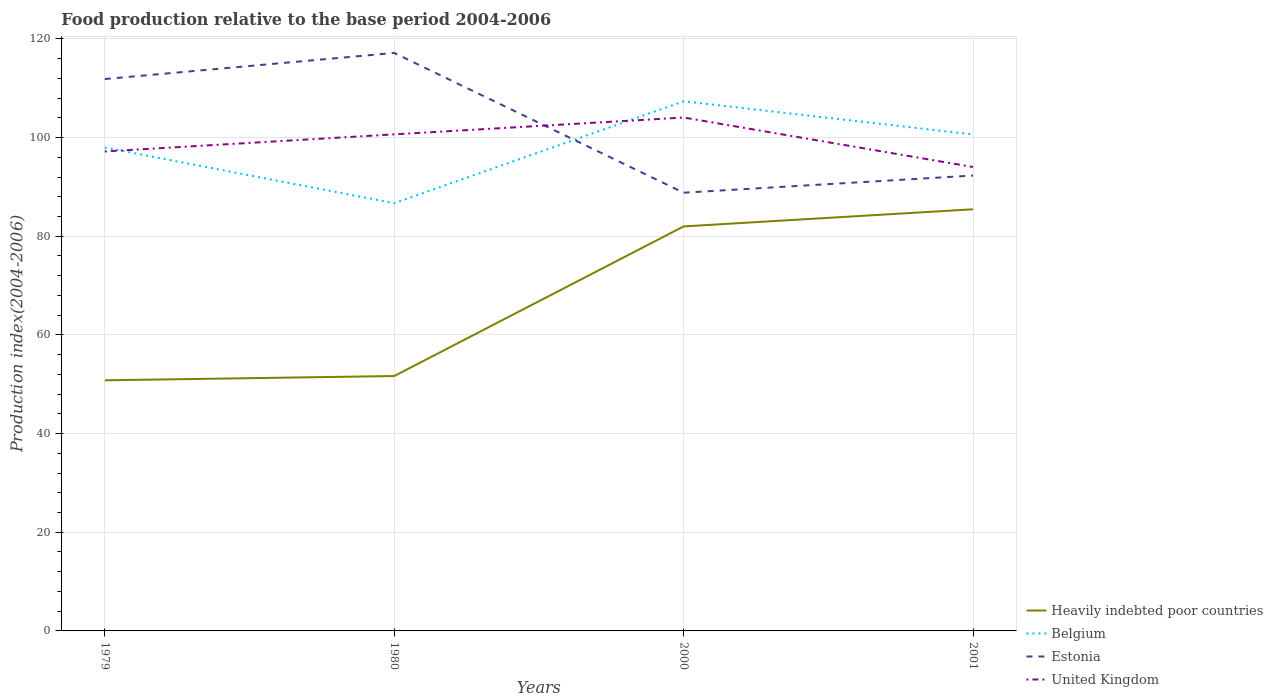How many different coloured lines are there?
Provide a succinct answer. 4. Does the line corresponding to Estonia intersect with the line corresponding to United Kingdom?
Your response must be concise. Yes. Across all years, what is the maximum food production index in Belgium?
Make the answer very short. 86.7. In which year was the food production index in Belgium maximum?
Offer a very short reply. 1980. What is the total food production index in Estonia in the graph?
Keep it short and to the point. 24.85. What is the difference between the highest and the second highest food production index in United Kingdom?
Give a very brief answer. 10.03. What is the difference between the highest and the lowest food production index in Estonia?
Provide a short and direct response. 2. How many years are there in the graph?
Your answer should be compact. 4. Does the graph contain any zero values?
Provide a succinct answer. No. How are the legend labels stacked?
Offer a very short reply. Vertical. What is the title of the graph?
Provide a short and direct response. Food production relative to the base period 2004-2006. Does "Trinidad and Tobago" appear as one of the legend labels in the graph?
Provide a short and direct response. No. What is the label or title of the X-axis?
Offer a terse response. Years. What is the label or title of the Y-axis?
Offer a terse response. Production index(2004-2006). What is the Production index(2004-2006) in Heavily indebted poor countries in 1979?
Provide a succinct answer. 50.8. What is the Production index(2004-2006) in Belgium in 1979?
Make the answer very short. 97.99. What is the Production index(2004-2006) of Estonia in 1979?
Your answer should be compact. 111.87. What is the Production index(2004-2006) of United Kingdom in 1979?
Offer a very short reply. 97.19. What is the Production index(2004-2006) of Heavily indebted poor countries in 1980?
Give a very brief answer. 51.67. What is the Production index(2004-2006) in Belgium in 1980?
Offer a terse response. 86.7. What is the Production index(2004-2006) of Estonia in 1980?
Provide a succinct answer. 117.16. What is the Production index(2004-2006) of United Kingdom in 1980?
Your response must be concise. 100.66. What is the Production index(2004-2006) in Heavily indebted poor countries in 2000?
Provide a succinct answer. 82. What is the Production index(2004-2006) in Belgium in 2000?
Offer a very short reply. 107.36. What is the Production index(2004-2006) of Estonia in 2000?
Keep it short and to the point. 88.83. What is the Production index(2004-2006) of United Kingdom in 2000?
Your answer should be compact. 104.07. What is the Production index(2004-2006) of Heavily indebted poor countries in 2001?
Offer a terse response. 85.47. What is the Production index(2004-2006) in Belgium in 2001?
Offer a very short reply. 100.64. What is the Production index(2004-2006) of Estonia in 2001?
Keep it short and to the point. 92.31. What is the Production index(2004-2006) in United Kingdom in 2001?
Your answer should be very brief. 94.04. Across all years, what is the maximum Production index(2004-2006) in Heavily indebted poor countries?
Your answer should be very brief. 85.47. Across all years, what is the maximum Production index(2004-2006) of Belgium?
Offer a terse response. 107.36. Across all years, what is the maximum Production index(2004-2006) in Estonia?
Provide a succinct answer. 117.16. Across all years, what is the maximum Production index(2004-2006) in United Kingdom?
Your answer should be compact. 104.07. Across all years, what is the minimum Production index(2004-2006) in Heavily indebted poor countries?
Make the answer very short. 50.8. Across all years, what is the minimum Production index(2004-2006) in Belgium?
Ensure brevity in your answer.  86.7. Across all years, what is the minimum Production index(2004-2006) in Estonia?
Give a very brief answer. 88.83. Across all years, what is the minimum Production index(2004-2006) in United Kingdom?
Your response must be concise. 94.04. What is the total Production index(2004-2006) of Heavily indebted poor countries in the graph?
Ensure brevity in your answer.  269.93. What is the total Production index(2004-2006) in Belgium in the graph?
Provide a succinct answer. 392.69. What is the total Production index(2004-2006) in Estonia in the graph?
Make the answer very short. 410.17. What is the total Production index(2004-2006) of United Kingdom in the graph?
Ensure brevity in your answer.  395.96. What is the difference between the Production index(2004-2006) of Heavily indebted poor countries in 1979 and that in 1980?
Offer a terse response. -0.87. What is the difference between the Production index(2004-2006) of Belgium in 1979 and that in 1980?
Provide a succinct answer. 11.29. What is the difference between the Production index(2004-2006) in Estonia in 1979 and that in 1980?
Your answer should be compact. -5.29. What is the difference between the Production index(2004-2006) in United Kingdom in 1979 and that in 1980?
Provide a succinct answer. -3.47. What is the difference between the Production index(2004-2006) of Heavily indebted poor countries in 1979 and that in 2000?
Make the answer very short. -31.2. What is the difference between the Production index(2004-2006) in Belgium in 1979 and that in 2000?
Keep it short and to the point. -9.37. What is the difference between the Production index(2004-2006) of Estonia in 1979 and that in 2000?
Provide a short and direct response. 23.04. What is the difference between the Production index(2004-2006) of United Kingdom in 1979 and that in 2000?
Offer a terse response. -6.88. What is the difference between the Production index(2004-2006) in Heavily indebted poor countries in 1979 and that in 2001?
Give a very brief answer. -34.67. What is the difference between the Production index(2004-2006) of Belgium in 1979 and that in 2001?
Your answer should be very brief. -2.65. What is the difference between the Production index(2004-2006) in Estonia in 1979 and that in 2001?
Your answer should be compact. 19.56. What is the difference between the Production index(2004-2006) of United Kingdom in 1979 and that in 2001?
Provide a succinct answer. 3.15. What is the difference between the Production index(2004-2006) in Heavily indebted poor countries in 1980 and that in 2000?
Give a very brief answer. -30.33. What is the difference between the Production index(2004-2006) of Belgium in 1980 and that in 2000?
Give a very brief answer. -20.66. What is the difference between the Production index(2004-2006) of Estonia in 1980 and that in 2000?
Give a very brief answer. 28.33. What is the difference between the Production index(2004-2006) of United Kingdom in 1980 and that in 2000?
Offer a very short reply. -3.41. What is the difference between the Production index(2004-2006) of Heavily indebted poor countries in 1980 and that in 2001?
Your answer should be compact. -33.8. What is the difference between the Production index(2004-2006) in Belgium in 1980 and that in 2001?
Provide a succinct answer. -13.94. What is the difference between the Production index(2004-2006) of Estonia in 1980 and that in 2001?
Provide a short and direct response. 24.85. What is the difference between the Production index(2004-2006) in United Kingdom in 1980 and that in 2001?
Your answer should be compact. 6.62. What is the difference between the Production index(2004-2006) in Heavily indebted poor countries in 2000 and that in 2001?
Offer a very short reply. -3.47. What is the difference between the Production index(2004-2006) of Belgium in 2000 and that in 2001?
Offer a terse response. 6.72. What is the difference between the Production index(2004-2006) in Estonia in 2000 and that in 2001?
Offer a very short reply. -3.48. What is the difference between the Production index(2004-2006) in United Kingdom in 2000 and that in 2001?
Offer a very short reply. 10.03. What is the difference between the Production index(2004-2006) in Heavily indebted poor countries in 1979 and the Production index(2004-2006) in Belgium in 1980?
Ensure brevity in your answer.  -35.9. What is the difference between the Production index(2004-2006) in Heavily indebted poor countries in 1979 and the Production index(2004-2006) in Estonia in 1980?
Ensure brevity in your answer.  -66.36. What is the difference between the Production index(2004-2006) of Heavily indebted poor countries in 1979 and the Production index(2004-2006) of United Kingdom in 1980?
Give a very brief answer. -49.86. What is the difference between the Production index(2004-2006) of Belgium in 1979 and the Production index(2004-2006) of Estonia in 1980?
Your response must be concise. -19.17. What is the difference between the Production index(2004-2006) in Belgium in 1979 and the Production index(2004-2006) in United Kingdom in 1980?
Keep it short and to the point. -2.67. What is the difference between the Production index(2004-2006) of Estonia in 1979 and the Production index(2004-2006) of United Kingdom in 1980?
Your answer should be very brief. 11.21. What is the difference between the Production index(2004-2006) in Heavily indebted poor countries in 1979 and the Production index(2004-2006) in Belgium in 2000?
Keep it short and to the point. -56.56. What is the difference between the Production index(2004-2006) of Heavily indebted poor countries in 1979 and the Production index(2004-2006) of Estonia in 2000?
Ensure brevity in your answer.  -38.03. What is the difference between the Production index(2004-2006) in Heavily indebted poor countries in 1979 and the Production index(2004-2006) in United Kingdom in 2000?
Provide a short and direct response. -53.27. What is the difference between the Production index(2004-2006) in Belgium in 1979 and the Production index(2004-2006) in Estonia in 2000?
Your answer should be compact. 9.16. What is the difference between the Production index(2004-2006) of Belgium in 1979 and the Production index(2004-2006) of United Kingdom in 2000?
Give a very brief answer. -6.08. What is the difference between the Production index(2004-2006) of Estonia in 1979 and the Production index(2004-2006) of United Kingdom in 2000?
Your response must be concise. 7.8. What is the difference between the Production index(2004-2006) in Heavily indebted poor countries in 1979 and the Production index(2004-2006) in Belgium in 2001?
Offer a terse response. -49.84. What is the difference between the Production index(2004-2006) of Heavily indebted poor countries in 1979 and the Production index(2004-2006) of Estonia in 2001?
Your answer should be very brief. -41.51. What is the difference between the Production index(2004-2006) of Heavily indebted poor countries in 1979 and the Production index(2004-2006) of United Kingdom in 2001?
Provide a succinct answer. -43.24. What is the difference between the Production index(2004-2006) of Belgium in 1979 and the Production index(2004-2006) of Estonia in 2001?
Offer a very short reply. 5.68. What is the difference between the Production index(2004-2006) of Belgium in 1979 and the Production index(2004-2006) of United Kingdom in 2001?
Keep it short and to the point. 3.95. What is the difference between the Production index(2004-2006) in Estonia in 1979 and the Production index(2004-2006) in United Kingdom in 2001?
Keep it short and to the point. 17.83. What is the difference between the Production index(2004-2006) in Heavily indebted poor countries in 1980 and the Production index(2004-2006) in Belgium in 2000?
Your answer should be very brief. -55.69. What is the difference between the Production index(2004-2006) in Heavily indebted poor countries in 1980 and the Production index(2004-2006) in Estonia in 2000?
Give a very brief answer. -37.16. What is the difference between the Production index(2004-2006) in Heavily indebted poor countries in 1980 and the Production index(2004-2006) in United Kingdom in 2000?
Make the answer very short. -52.4. What is the difference between the Production index(2004-2006) of Belgium in 1980 and the Production index(2004-2006) of Estonia in 2000?
Your answer should be very brief. -2.13. What is the difference between the Production index(2004-2006) in Belgium in 1980 and the Production index(2004-2006) in United Kingdom in 2000?
Provide a succinct answer. -17.37. What is the difference between the Production index(2004-2006) of Estonia in 1980 and the Production index(2004-2006) of United Kingdom in 2000?
Your answer should be compact. 13.09. What is the difference between the Production index(2004-2006) in Heavily indebted poor countries in 1980 and the Production index(2004-2006) in Belgium in 2001?
Ensure brevity in your answer.  -48.97. What is the difference between the Production index(2004-2006) of Heavily indebted poor countries in 1980 and the Production index(2004-2006) of Estonia in 2001?
Keep it short and to the point. -40.64. What is the difference between the Production index(2004-2006) in Heavily indebted poor countries in 1980 and the Production index(2004-2006) in United Kingdom in 2001?
Ensure brevity in your answer.  -42.37. What is the difference between the Production index(2004-2006) in Belgium in 1980 and the Production index(2004-2006) in Estonia in 2001?
Provide a succinct answer. -5.61. What is the difference between the Production index(2004-2006) in Belgium in 1980 and the Production index(2004-2006) in United Kingdom in 2001?
Your response must be concise. -7.34. What is the difference between the Production index(2004-2006) of Estonia in 1980 and the Production index(2004-2006) of United Kingdom in 2001?
Offer a terse response. 23.12. What is the difference between the Production index(2004-2006) of Heavily indebted poor countries in 2000 and the Production index(2004-2006) of Belgium in 2001?
Your answer should be very brief. -18.64. What is the difference between the Production index(2004-2006) in Heavily indebted poor countries in 2000 and the Production index(2004-2006) in Estonia in 2001?
Provide a succinct answer. -10.31. What is the difference between the Production index(2004-2006) of Heavily indebted poor countries in 2000 and the Production index(2004-2006) of United Kingdom in 2001?
Your response must be concise. -12.04. What is the difference between the Production index(2004-2006) of Belgium in 2000 and the Production index(2004-2006) of Estonia in 2001?
Ensure brevity in your answer.  15.05. What is the difference between the Production index(2004-2006) in Belgium in 2000 and the Production index(2004-2006) in United Kingdom in 2001?
Your answer should be compact. 13.32. What is the difference between the Production index(2004-2006) of Estonia in 2000 and the Production index(2004-2006) of United Kingdom in 2001?
Make the answer very short. -5.21. What is the average Production index(2004-2006) in Heavily indebted poor countries per year?
Ensure brevity in your answer.  67.48. What is the average Production index(2004-2006) of Belgium per year?
Give a very brief answer. 98.17. What is the average Production index(2004-2006) of Estonia per year?
Make the answer very short. 102.54. What is the average Production index(2004-2006) in United Kingdom per year?
Offer a terse response. 98.99. In the year 1979, what is the difference between the Production index(2004-2006) in Heavily indebted poor countries and Production index(2004-2006) in Belgium?
Ensure brevity in your answer.  -47.19. In the year 1979, what is the difference between the Production index(2004-2006) in Heavily indebted poor countries and Production index(2004-2006) in Estonia?
Your answer should be very brief. -61.07. In the year 1979, what is the difference between the Production index(2004-2006) of Heavily indebted poor countries and Production index(2004-2006) of United Kingdom?
Provide a succinct answer. -46.39. In the year 1979, what is the difference between the Production index(2004-2006) in Belgium and Production index(2004-2006) in Estonia?
Provide a succinct answer. -13.88. In the year 1979, what is the difference between the Production index(2004-2006) in Estonia and Production index(2004-2006) in United Kingdom?
Offer a terse response. 14.68. In the year 1980, what is the difference between the Production index(2004-2006) in Heavily indebted poor countries and Production index(2004-2006) in Belgium?
Offer a terse response. -35.03. In the year 1980, what is the difference between the Production index(2004-2006) of Heavily indebted poor countries and Production index(2004-2006) of Estonia?
Your answer should be very brief. -65.49. In the year 1980, what is the difference between the Production index(2004-2006) in Heavily indebted poor countries and Production index(2004-2006) in United Kingdom?
Keep it short and to the point. -48.99. In the year 1980, what is the difference between the Production index(2004-2006) of Belgium and Production index(2004-2006) of Estonia?
Offer a terse response. -30.46. In the year 1980, what is the difference between the Production index(2004-2006) in Belgium and Production index(2004-2006) in United Kingdom?
Make the answer very short. -13.96. In the year 2000, what is the difference between the Production index(2004-2006) in Heavily indebted poor countries and Production index(2004-2006) in Belgium?
Your response must be concise. -25.36. In the year 2000, what is the difference between the Production index(2004-2006) of Heavily indebted poor countries and Production index(2004-2006) of Estonia?
Provide a succinct answer. -6.83. In the year 2000, what is the difference between the Production index(2004-2006) in Heavily indebted poor countries and Production index(2004-2006) in United Kingdom?
Ensure brevity in your answer.  -22.07. In the year 2000, what is the difference between the Production index(2004-2006) of Belgium and Production index(2004-2006) of Estonia?
Provide a short and direct response. 18.53. In the year 2000, what is the difference between the Production index(2004-2006) of Belgium and Production index(2004-2006) of United Kingdom?
Provide a short and direct response. 3.29. In the year 2000, what is the difference between the Production index(2004-2006) in Estonia and Production index(2004-2006) in United Kingdom?
Provide a succinct answer. -15.24. In the year 2001, what is the difference between the Production index(2004-2006) in Heavily indebted poor countries and Production index(2004-2006) in Belgium?
Your answer should be very brief. -15.17. In the year 2001, what is the difference between the Production index(2004-2006) of Heavily indebted poor countries and Production index(2004-2006) of Estonia?
Keep it short and to the point. -6.84. In the year 2001, what is the difference between the Production index(2004-2006) in Heavily indebted poor countries and Production index(2004-2006) in United Kingdom?
Make the answer very short. -8.57. In the year 2001, what is the difference between the Production index(2004-2006) of Belgium and Production index(2004-2006) of Estonia?
Your answer should be compact. 8.33. In the year 2001, what is the difference between the Production index(2004-2006) in Estonia and Production index(2004-2006) in United Kingdom?
Offer a terse response. -1.73. What is the ratio of the Production index(2004-2006) in Heavily indebted poor countries in 1979 to that in 1980?
Give a very brief answer. 0.98. What is the ratio of the Production index(2004-2006) of Belgium in 1979 to that in 1980?
Offer a terse response. 1.13. What is the ratio of the Production index(2004-2006) of Estonia in 1979 to that in 1980?
Ensure brevity in your answer.  0.95. What is the ratio of the Production index(2004-2006) of United Kingdom in 1979 to that in 1980?
Give a very brief answer. 0.97. What is the ratio of the Production index(2004-2006) of Heavily indebted poor countries in 1979 to that in 2000?
Your answer should be very brief. 0.62. What is the ratio of the Production index(2004-2006) in Belgium in 1979 to that in 2000?
Provide a succinct answer. 0.91. What is the ratio of the Production index(2004-2006) of Estonia in 1979 to that in 2000?
Make the answer very short. 1.26. What is the ratio of the Production index(2004-2006) in United Kingdom in 1979 to that in 2000?
Your response must be concise. 0.93. What is the ratio of the Production index(2004-2006) in Heavily indebted poor countries in 1979 to that in 2001?
Provide a succinct answer. 0.59. What is the ratio of the Production index(2004-2006) of Belgium in 1979 to that in 2001?
Your answer should be very brief. 0.97. What is the ratio of the Production index(2004-2006) in Estonia in 1979 to that in 2001?
Ensure brevity in your answer.  1.21. What is the ratio of the Production index(2004-2006) of United Kingdom in 1979 to that in 2001?
Keep it short and to the point. 1.03. What is the ratio of the Production index(2004-2006) in Heavily indebted poor countries in 1980 to that in 2000?
Give a very brief answer. 0.63. What is the ratio of the Production index(2004-2006) of Belgium in 1980 to that in 2000?
Keep it short and to the point. 0.81. What is the ratio of the Production index(2004-2006) of Estonia in 1980 to that in 2000?
Make the answer very short. 1.32. What is the ratio of the Production index(2004-2006) in United Kingdom in 1980 to that in 2000?
Provide a short and direct response. 0.97. What is the ratio of the Production index(2004-2006) of Heavily indebted poor countries in 1980 to that in 2001?
Make the answer very short. 0.6. What is the ratio of the Production index(2004-2006) of Belgium in 1980 to that in 2001?
Your answer should be compact. 0.86. What is the ratio of the Production index(2004-2006) of Estonia in 1980 to that in 2001?
Your response must be concise. 1.27. What is the ratio of the Production index(2004-2006) of United Kingdom in 1980 to that in 2001?
Your answer should be very brief. 1.07. What is the ratio of the Production index(2004-2006) in Heavily indebted poor countries in 2000 to that in 2001?
Offer a terse response. 0.96. What is the ratio of the Production index(2004-2006) in Belgium in 2000 to that in 2001?
Your answer should be very brief. 1.07. What is the ratio of the Production index(2004-2006) in Estonia in 2000 to that in 2001?
Give a very brief answer. 0.96. What is the ratio of the Production index(2004-2006) in United Kingdom in 2000 to that in 2001?
Ensure brevity in your answer.  1.11. What is the difference between the highest and the second highest Production index(2004-2006) in Heavily indebted poor countries?
Provide a succinct answer. 3.47. What is the difference between the highest and the second highest Production index(2004-2006) of Belgium?
Provide a succinct answer. 6.72. What is the difference between the highest and the second highest Production index(2004-2006) in Estonia?
Keep it short and to the point. 5.29. What is the difference between the highest and the second highest Production index(2004-2006) of United Kingdom?
Provide a succinct answer. 3.41. What is the difference between the highest and the lowest Production index(2004-2006) of Heavily indebted poor countries?
Ensure brevity in your answer.  34.67. What is the difference between the highest and the lowest Production index(2004-2006) in Belgium?
Your answer should be very brief. 20.66. What is the difference between the highest and the lowest Production index(2004-2006) of Estonia?
Keep it short and to the point. 28.33. What is the difference between the highest and the lowest Production index(2004-2006) of United Kingdom?
Offer a terse response. 10.03. 